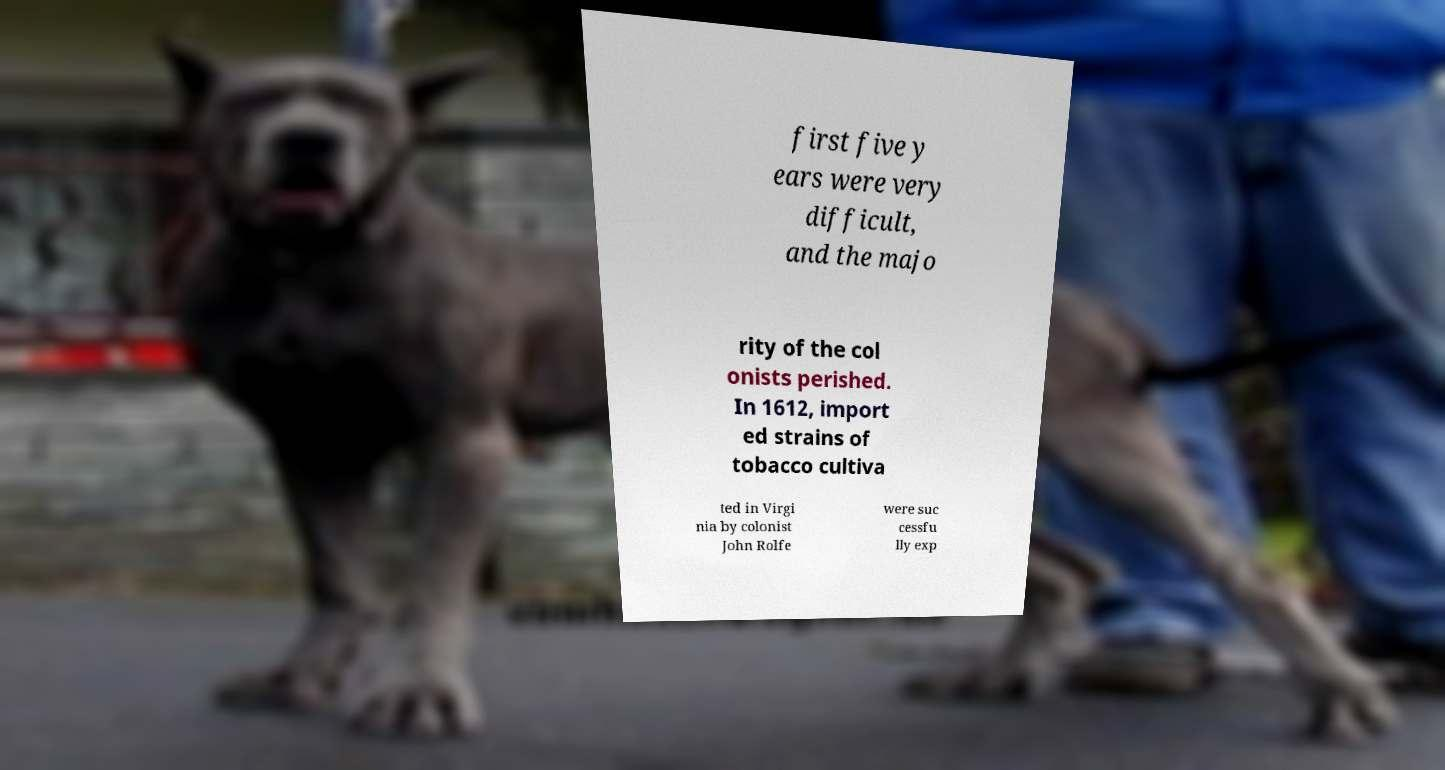Can you read and provide the text displayed in the image?This photo seems to have some interesting text. Can you extract and type it out for me? first five y ears were very difficult, and the majo rity of the col onists perished. In 1612, import ed strains of tobacco cultiva ted in Virgi nia by colonist John Rolfe were suc cessfu lly exp 